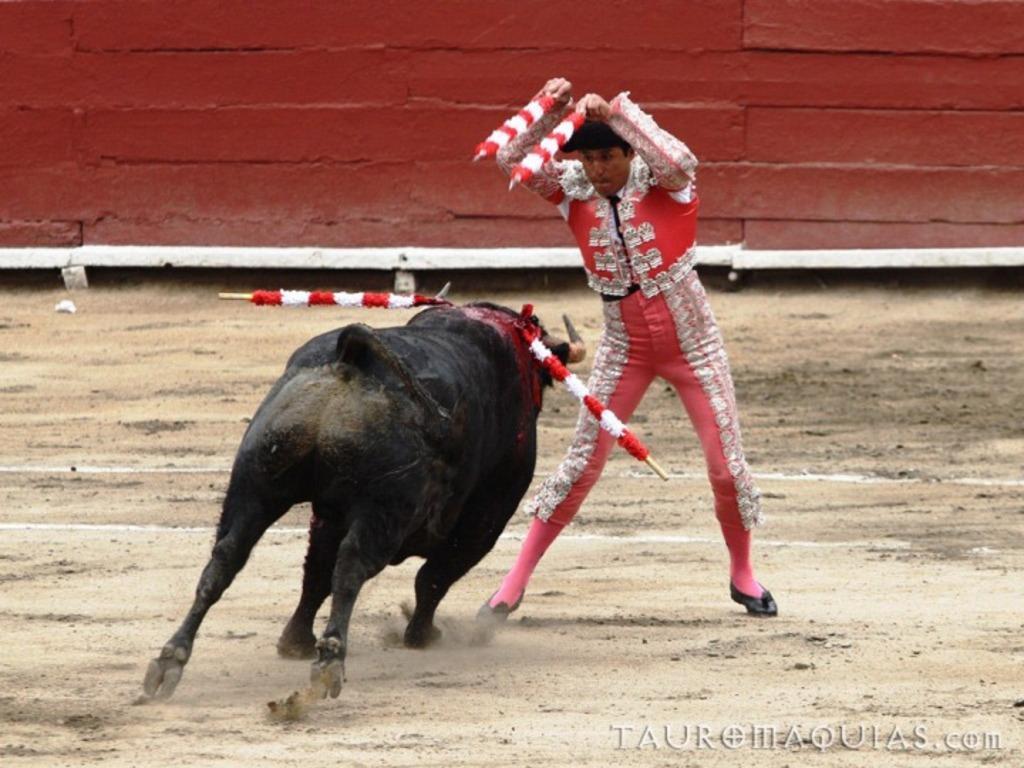Can you describe this image briefly? There is a man in motion and holding objects,in front of him we can see a bull. In the background we can see wall. Right side of the image we can see watermark. 